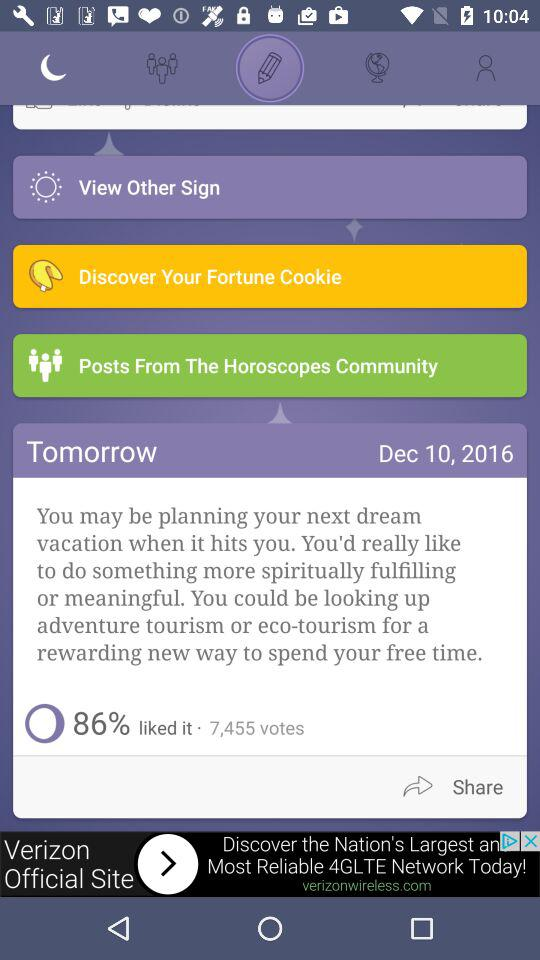What is the percentage of likes? The percentage is 86. 